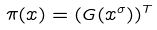Convert formula to latex. <formula><loc_0><loc_0><loc_500><loc_500>\pi ( x ) = ( G ( x ^ { \sigma } ) ) ^ { T }</formula> 